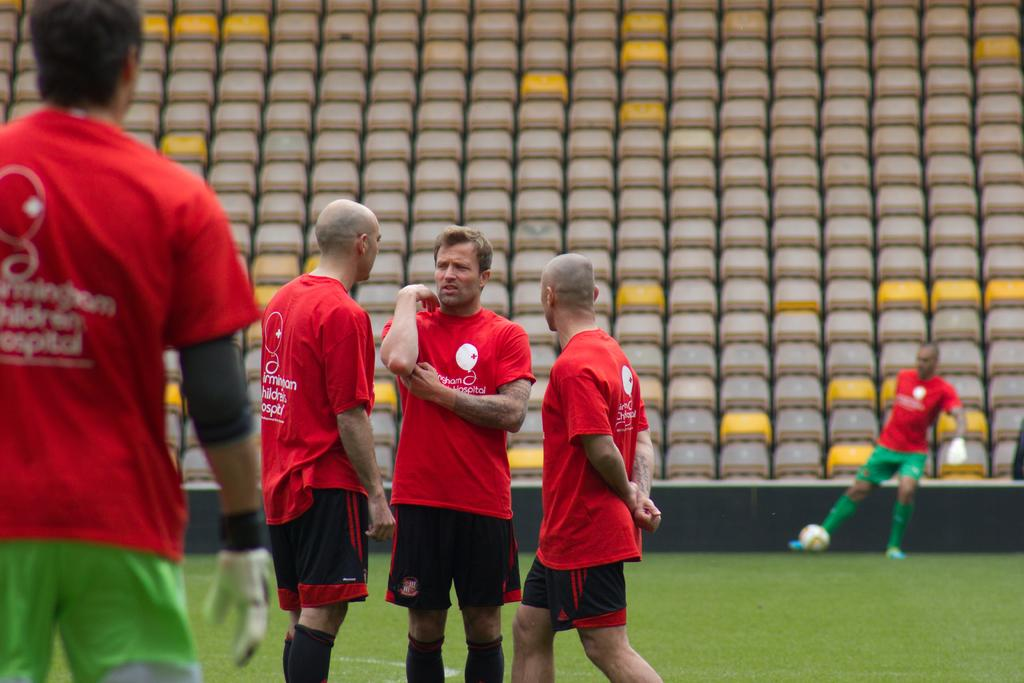How many people are present in the image? There are five persons in the image. What type of surface is the ground in the image? The ground in the image is grass. What object can be seen in the image besides the people? There is a ball visible in the image. What color is the thumb of the person on the left in the image? There is no thumb visible in the image, as it only shows five persons and a ball on a grassy surface. 